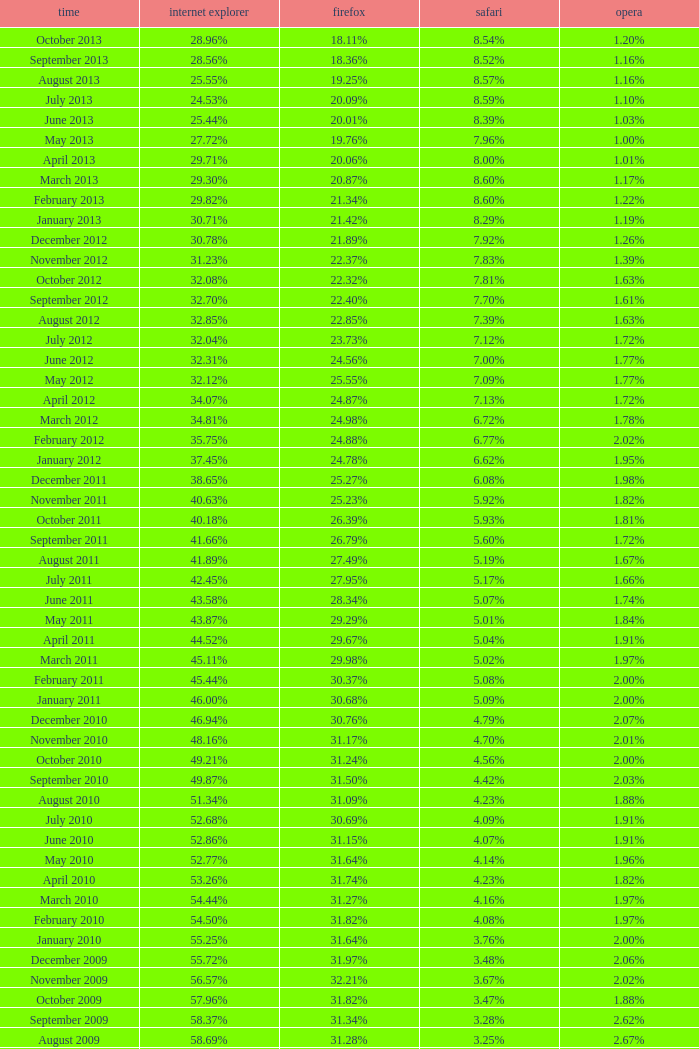What percentage of browsers were using Internet Explorer in April 2009? 61.88%. 